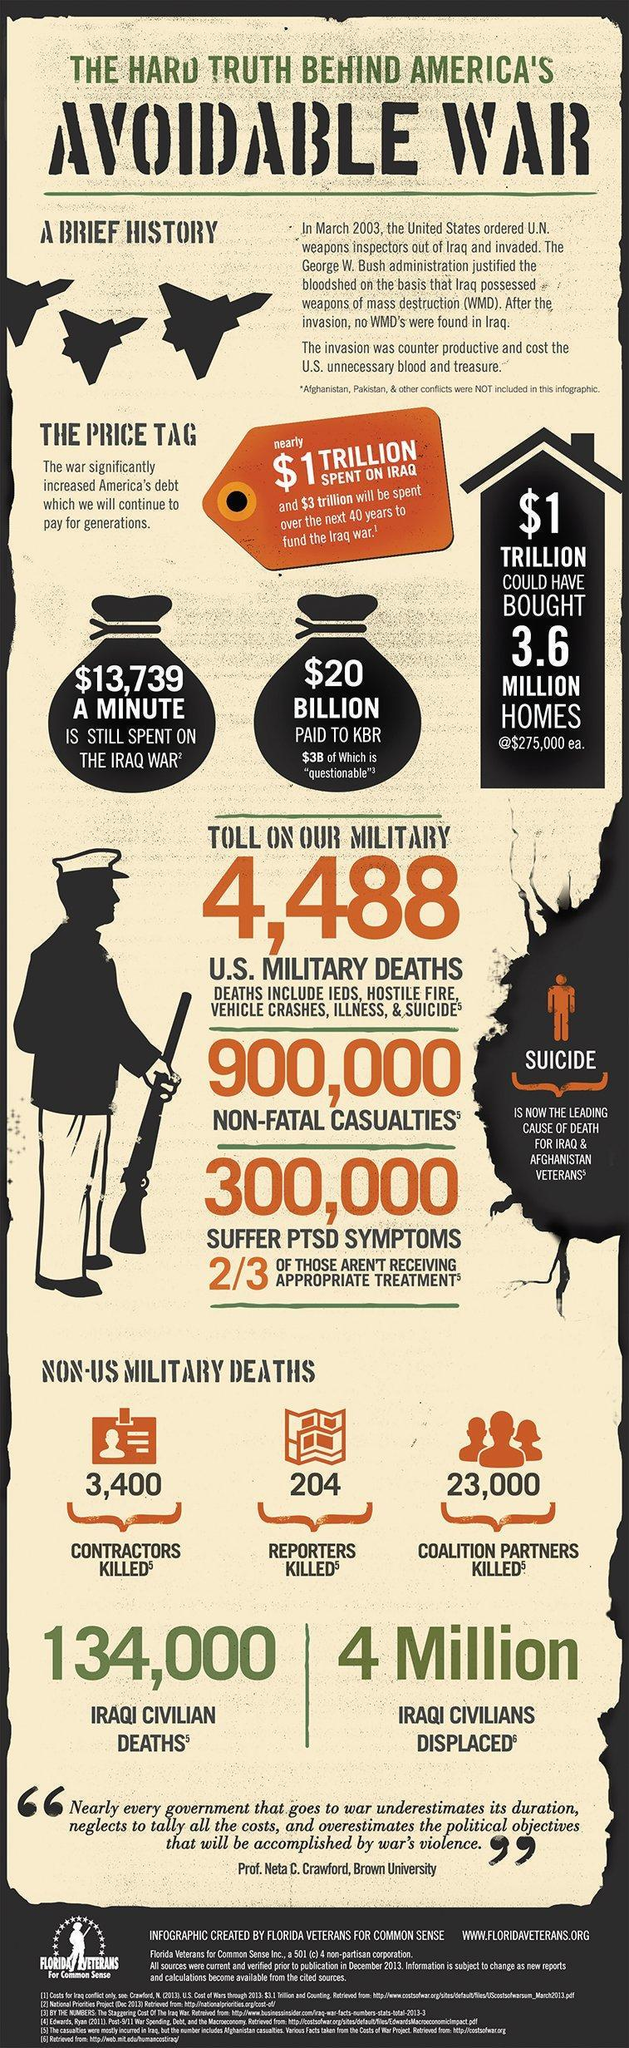How many contractors and reporters were killed?
Answer the question with a short phrase. 3,604 Which organization is mentioned? FLORIDA VETERANS FOR COMMON SENSE What is the website of the organization given? WWW.FLORIDAVETERANS.ORG 